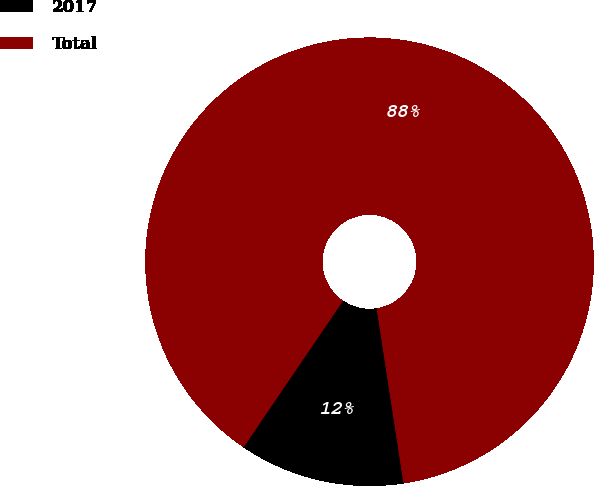<chart> <loc_0><loc_0><loc_500><loc_500><pie_chart><fcel>2017<fcel>Total<nl><fcel>11.92%<fcel>88.08%<nl></chart> 